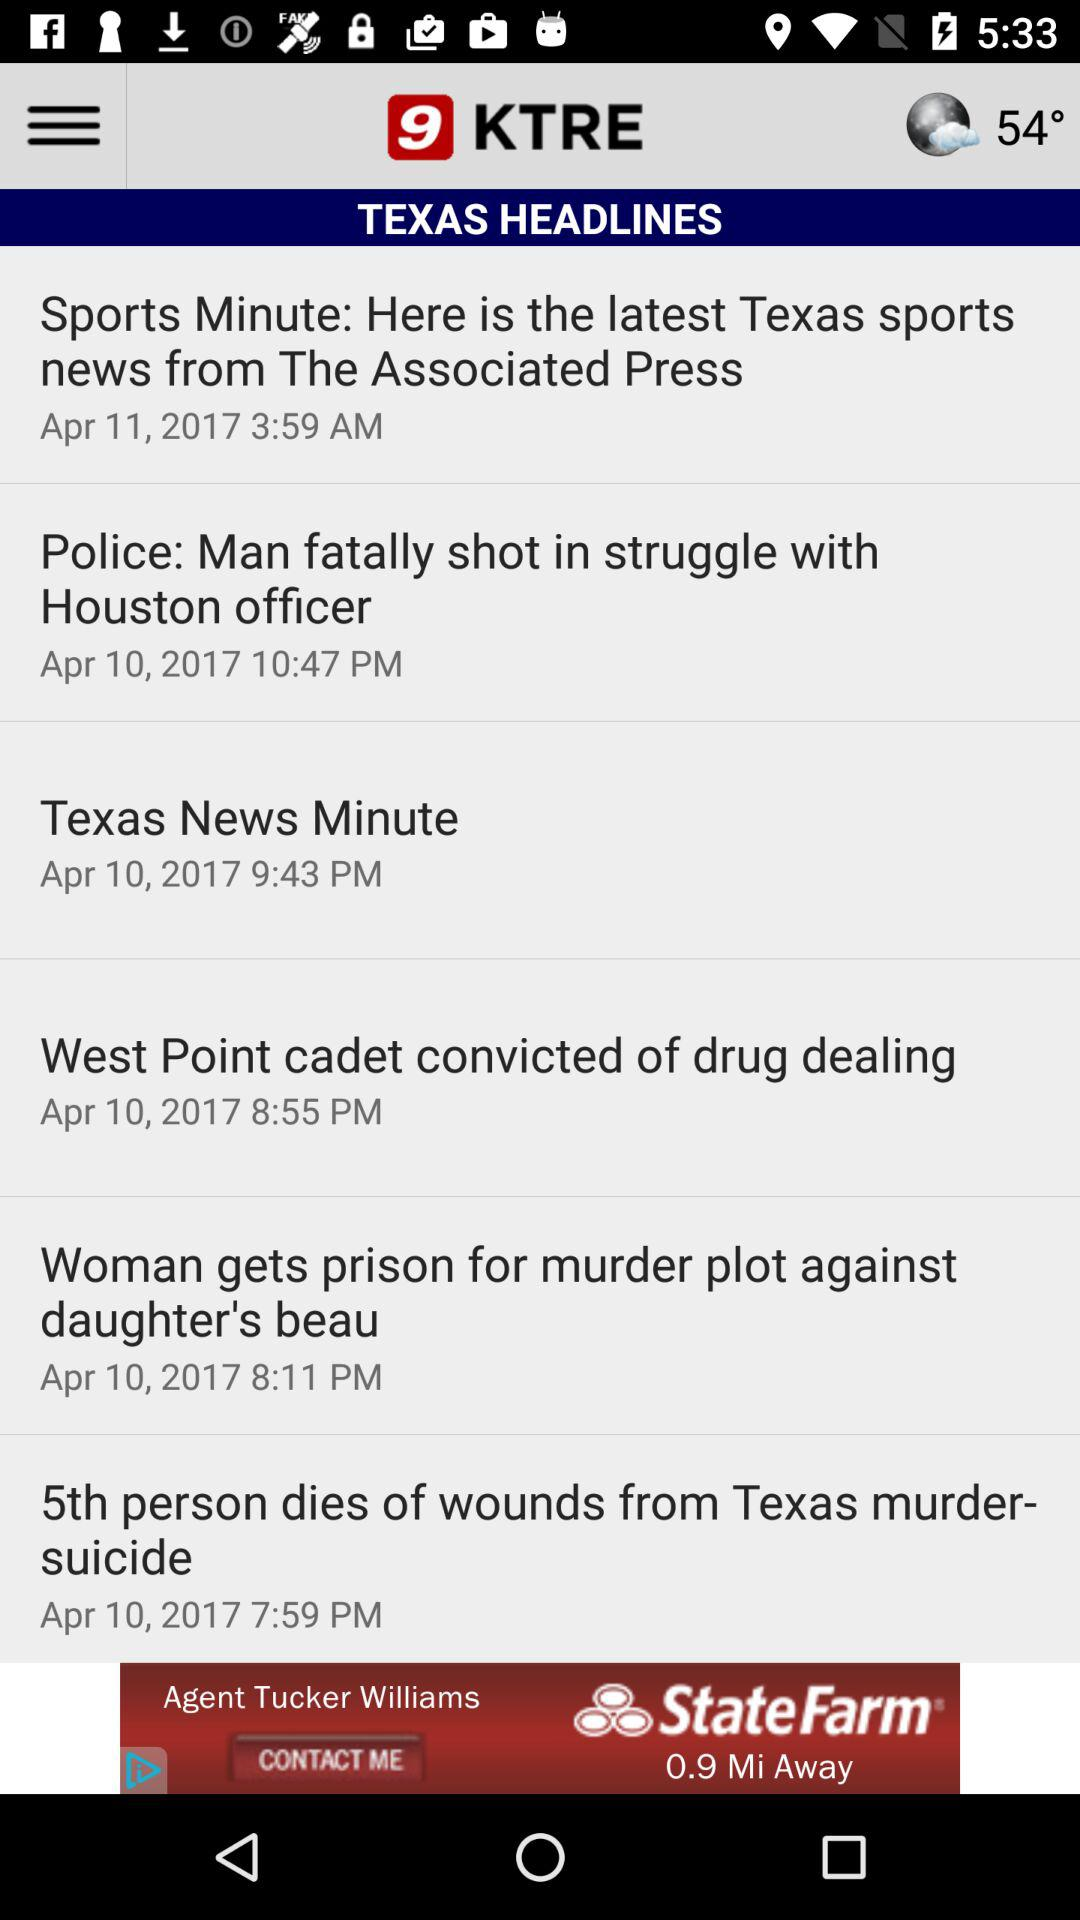What is the shown temperature? The shown temperature is 54°. 